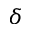Convert formula to latex. <formula><loc_0><loc_0><loc_500><loc_500>\delta</formula> 